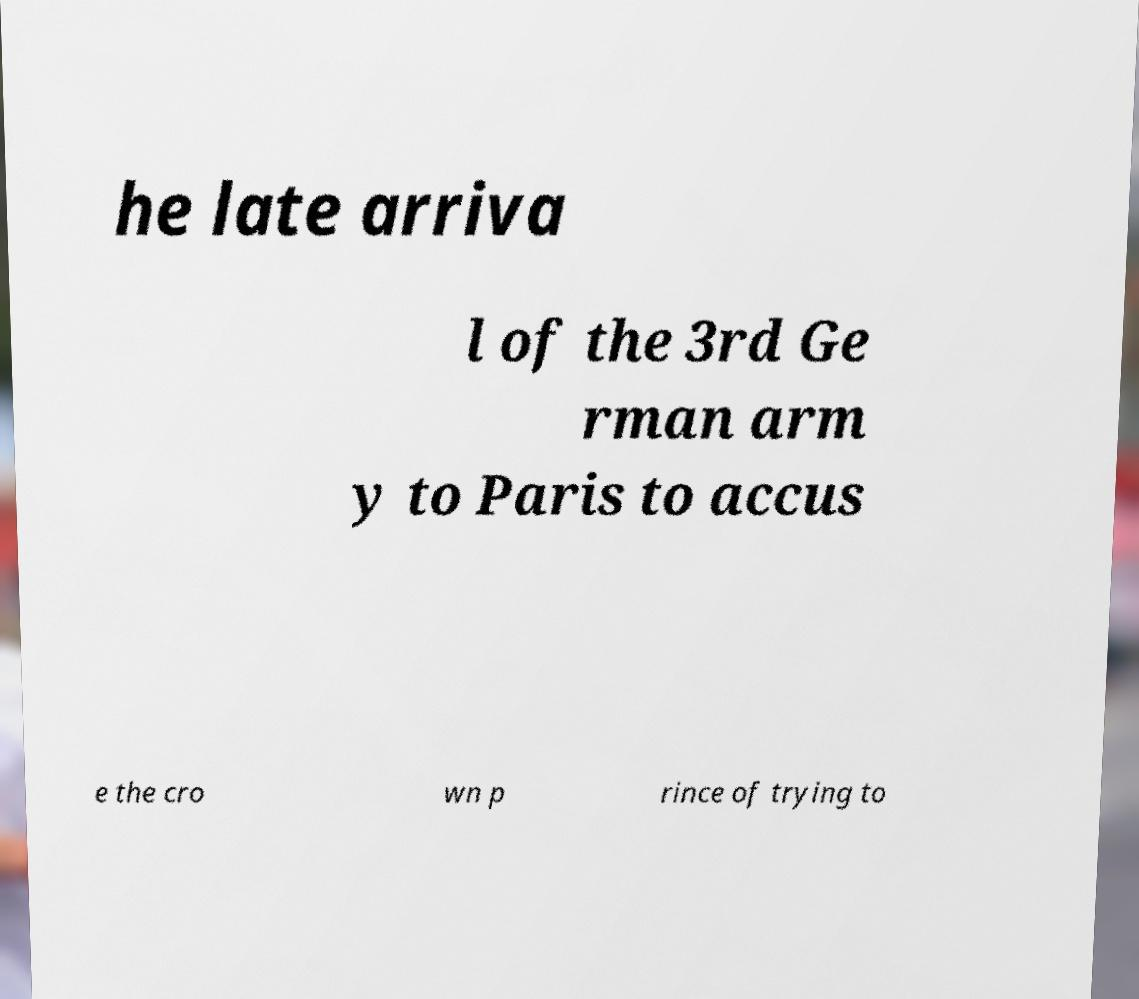There's text embedded in this image that I need extracted. Can you transcribe it verbatim? he late arriva l of the 3rd Ge rman arm y to Paris to accus e the cro wn p rince of trying to 